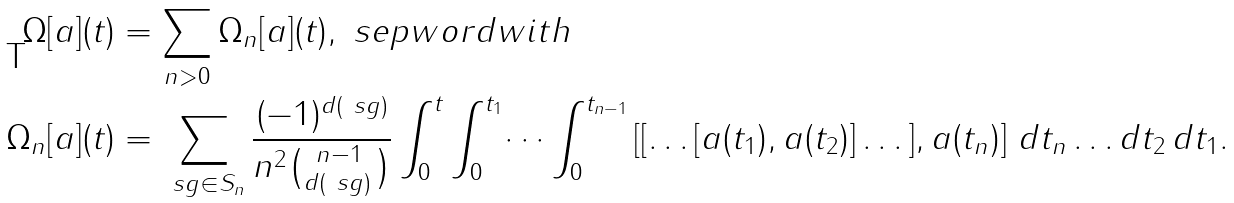Convert formula to latex. <formula><loc_0><loc_0><loc_500><loc_500>\Omega [ a ] ( t ) & = \sum _ { n > 0 } \Omega _ { n } [ a ] ( t ) , \ s e p w o r d { w i t h } \\ \Omega _ { n } [ a ] ( t ) & = \sum _ { \ s g \in S _ { n } } \frac { ( - 1 ) ^ { d ( \ s g ) } } { n ^ { 2 } \binom { n - 1 } { d ( \ s g ) \, } } \int _ { 0 } ^ { t } \int _ { 0 } ^ { t _ { 1 } } \dots \int _ { 0 } ^ { t _ { n - 1 } } \left [ [ \dots [ a ( t _ { 1 } ) , a ( t _ { 2 } ) ] \dots ] , a ( t _ { n } ) \right ] \, d t _ { n } \dots d t _ { 2 } \, d t _ { 1 } .</formula> 